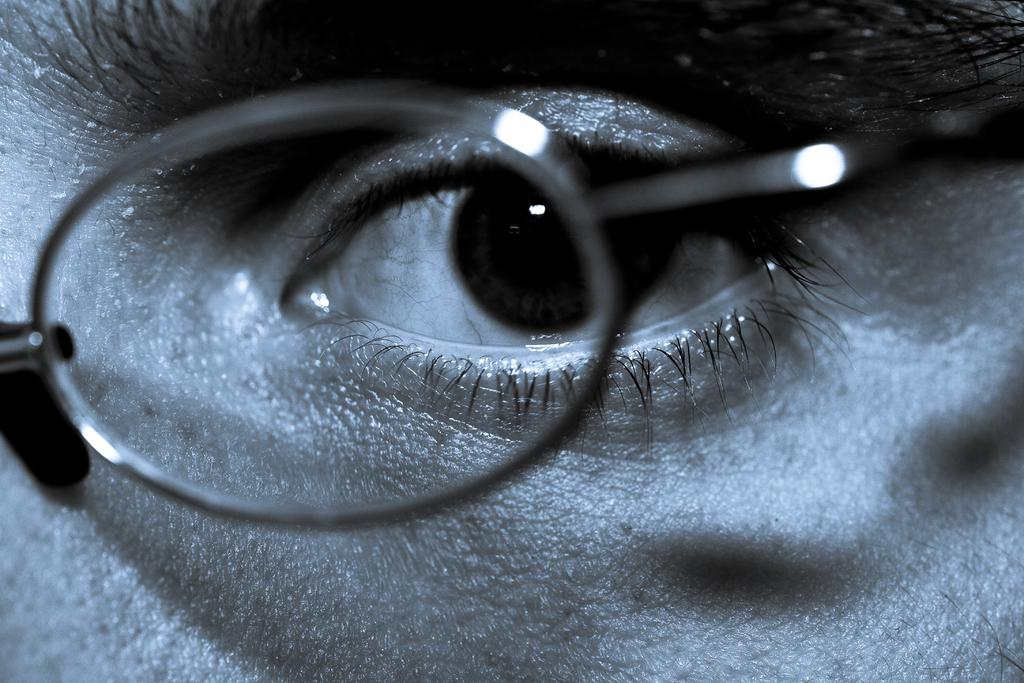What part of a person's body is visible in the image? There is an eye of a person in the image. What accessory is present in the image? There are glasses in the image. How many cents are visible in the image? There are no cents present in the image. What type of engine can be seen in the image? There is no engine present in the image. 